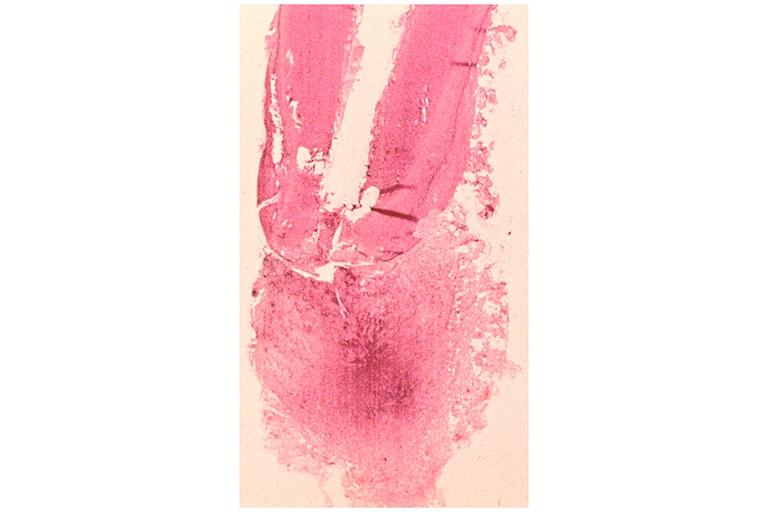does this image show periapical granuloma?
Answer the question using a single word or phrase. Yes 